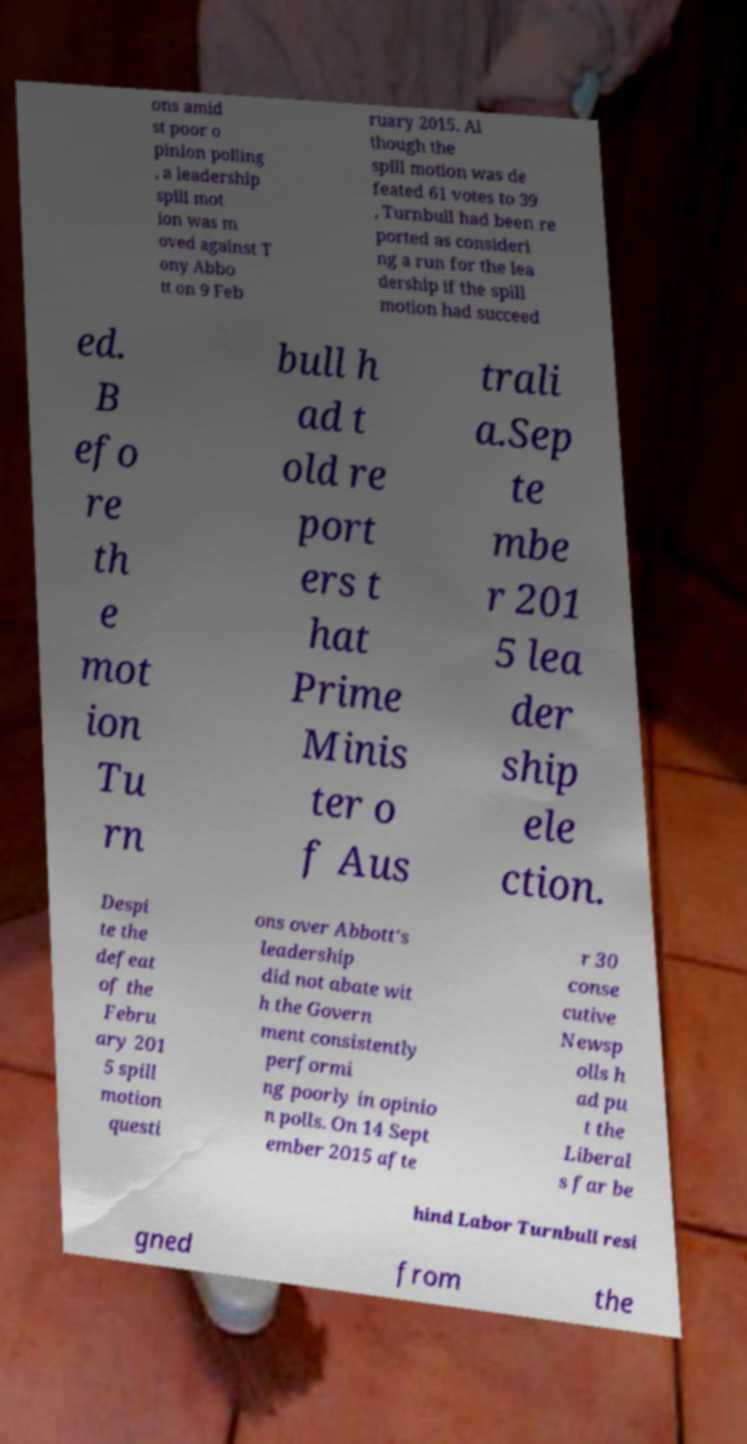I need the written content from this picture converted into text. Can you do that? ons amid st poor o pinion polling , a leadership spill mot ion was m oved against T ony Abbo tt on 9 Feb ruary 2015. Al though the spill motion was de feated 61 votes to 39 , Turnbull had been re ported as consideri ng a run for the lea dership if the spill motion had succeed ed. B efo re th e mot ion Tu rn bull h ad t old re port ers t hat Prime Minis ter o f Aus trali a.Sep te mbe r 201 5 lea der ship ele ction. Despi te the defeat of the Febru ary 201 5 spill motion questi ons over Abbott's leadership did not abate wit h the Govern ment consistently performi ng poorly in opinio n polls. On 14 Sept ember 2015 afte r 30 conse cutive Newsp olls h ad pu t the Liberal s far be hind Labor Turnbull resi gned from the 